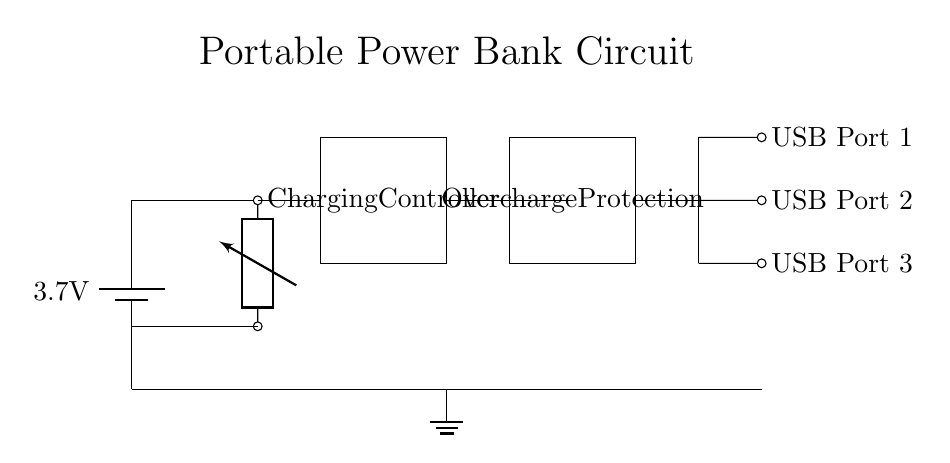What is the voltage of the battery? The circuit diagram indicates that the battery is marked with a voltage of 3.7 volts. This is shown directly in the symbol depicting the battery.
Answer: 3.7 volts What is the function of the boost converter? The boost converter in the circuit is labeled as a component that steps up the voltage. It connects to the battery above and allows for increased voltage output to charge USB devices.
Answer: Voltage step-up How many USB ports are available in the circuit? There are three USB ports depicted in the circuit diagram, each labeled individually. They are positioned at the right side of the diagram, clearly represented with connections.
Answer: Three What component provides overcharge protection? The overcharge protection component is distinctly indicated by a rectangle labeled "Overcharge Protection," which is connected between the charging controller and the USB ports.
Answer: Overcharge protection What connects the charging controller to the boost converter? A direct connection is shown between the charging controller and the boost converter, indicated by a line of connection that runs horizontally between these components.
Answer: Charging connection What type of circuit is represented by the arrangement of components? The diagram represents a portable power bank circuit characterized by its ability to store energy and provide power to multiple devices through USB charging ports.
Answer: Portable power bank circuit 